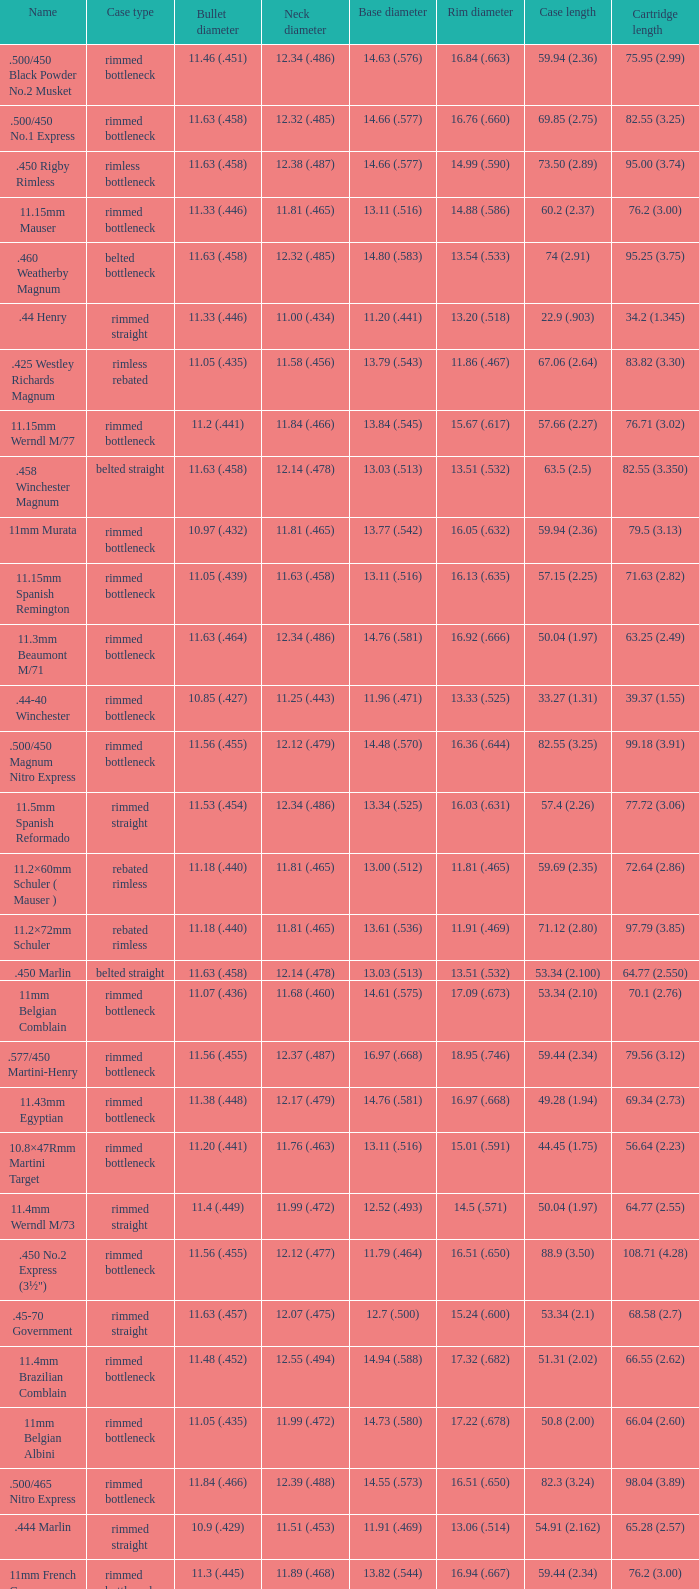Which Rim diameter has a Neck diameter of 11.84 (.466)? 15.67 (.617). 